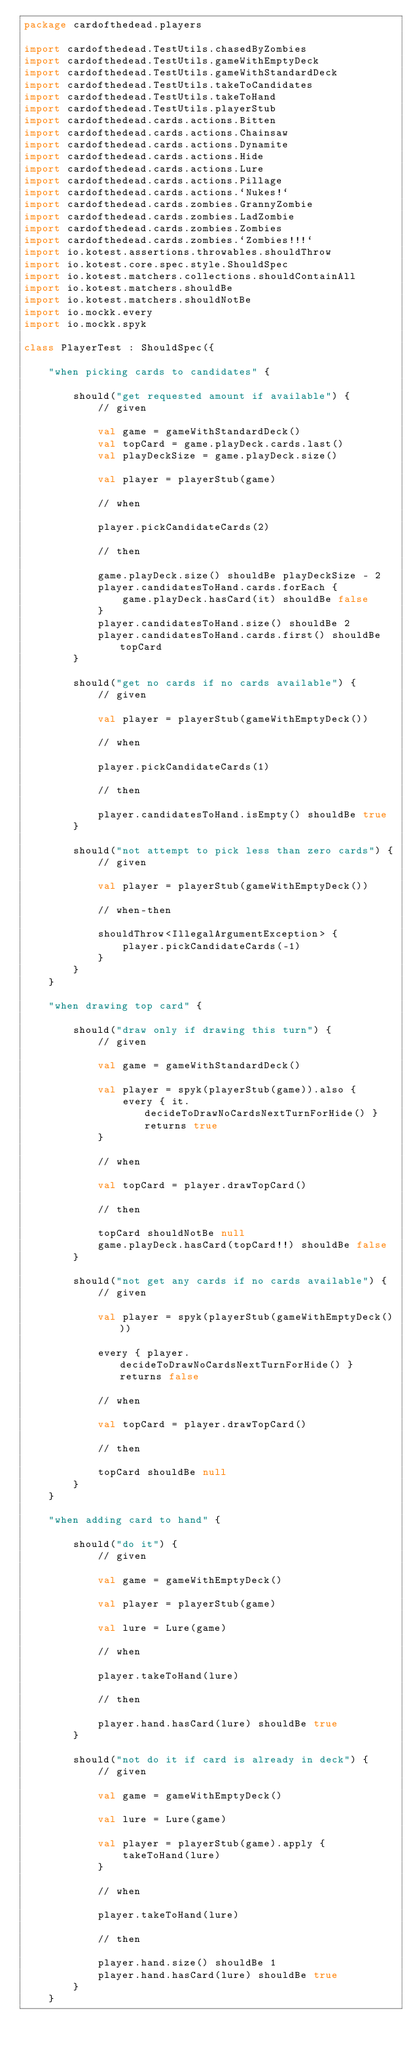Convert code to text. <code><loc_0><loc_0><loc_500><loc_500><_Kotlin_>package cardofthedead.players

import cardofthedead.TestUtils.chasedByZombies
import cardofthedead.TestUtils.gameWithEmptyDeck
import cardofthedead.TestUtils.gameWithStandardDeck
import cardofthedead.TestUtils.takeToCandidates
import cardofthedead.TestUtils.takeToHand
import cardofthedead.TestUtils.playerStub
import cardofthedead.cards.actions.Bitten
import cardofthedead.cards.actions.Chainsaw
import cardofthedead.cards.actions.Dynamite
import cardofthedead.cards.actions.Hide
import cardofthedead.cards.actions.Lure
import cardofthedead.cards.actions.Pillage
import cardofthedead.cards.actions.`Nukes!`
import cardofthedead.cards.zombies.GrannyZombie
import cardofthedead.cards.zombies.LadZombie
import cardofthedead.cards.zombies.Zombies
import cardofthedead.cards.zombies.`Zombies!!!`
import io.kotest.assertions.throwables.shouldThrow
import io.kotest.core.spec.style.ShouldSpec
import io.kotest.matchers.collections.shouldContainAll
import io.kotest.matchers.shouldBe
import io.kotest.matchers.shouldNotBe
import io.mockk.every
import io.mockk.spyk

class PlayerTest : ShouldSpec({

    "when picking cards to candidates" {

        should("get requested amount if available") {
            // given

            val game = gameWithStandardDeck()
            val topCard = game.playDeck.cards.last()
            val playDeckSize = game.playDeck.size()

            val player = playerStub(game)

            // when

            player.pickCandidateCards(2)

            // then

            game.playDeck.size() shouldBe playDeckSize - 2
            player.candidatesToHand.cards.forEach {
                game.playDeck.hasCard(it) shouldBe false
            }
            player.candidatesToHand.size() shouldBe 2
            player.candidatesToHand.cards.first() shouldBe topCard
        }

        should("get no cards if no cards available") {
            // given

            val player = playerStub(gameWithEmptyDeck())

            // when

            player.pickCandidateCards(1)

            // then

            player.candidatesToHand.isEmpty() shouldBe true
        }

        should("not attempt to pick less than zero cards") {
            // given

            val player = playerStub(gameWithEmptyDeck())

            // when-then

            shouldThrow<IllegalArgumentException> {
                player.pickCandidateCards(-1)
            }
        }
    }

    "when drawing top card" {

        should("draw only if drawing this turn") {
            // given

            val game = gameWithStandardDeck()

            val player = spyk(playerStub(game)).also {
                every { it.decideToDrawNoCardsNextTurnForHide() } returns true
            }

            // when

            val topCard = player.drawTopCard()

            // then

            topCard shouldNotBe null
            game.playDeck.hasCard(topCard!!) shouldBe false
        }

        should("not get any cards if no cards available") {
            // given

            val player = spyk(playerStub(gameWithEmptyDeck()))

            every { player.decideToDrawNoCardsNextTurnForHide() } returns false

            // when

            val topCard = player.drawTopCard()

            // then

            topCard shouldBe null
        }
    }

    "when adding card to hand" {

        should("do it") {
            // given

            val game = gameWithEmptyDeck()

            val player = playerStub(game)

            val lure = Lure(game)

            // when

            player.takeToHand(lure)

            // then

            player.hand.hasCard(lure) shouldBe true
        }

        should("not do it if card is already in deck") {
            // given

            val game = gameWithEmptyDeck()

            val lure = Lure(game)

            val player = playerStub(game).apply {
                takeToHand(lure)
            }

            // when

            player.takeToHand(lure)

            // then

            player.hand.size() shouldBe 1
            player.hand.hasCard(lure) shouldBe true
        }
    }
</code> 